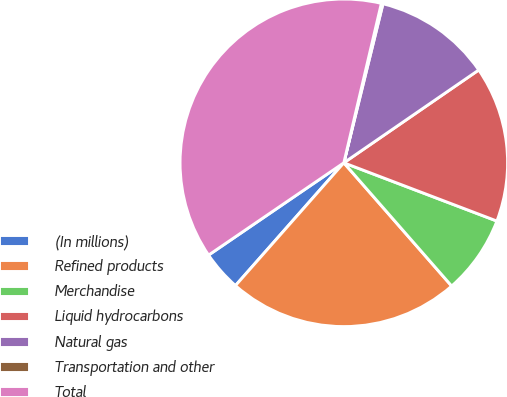Convert chart. <chart><loc_0><loc_0><loc_500><loc_500><pie_chart><fcel>(In millions)<fcel>Refined products<fcel>Merchandise<fcel>Liquid hydrocarbons<fcel>Natural gas<fcel>Transportation and other<fcel>Total<nl><fcel>3.96%<fcel>22.95%<fcel>7.77%<fcel>15.38%<fcel>11.57%<fcel>0.16%<fcel>38.21%<nl></chart> 